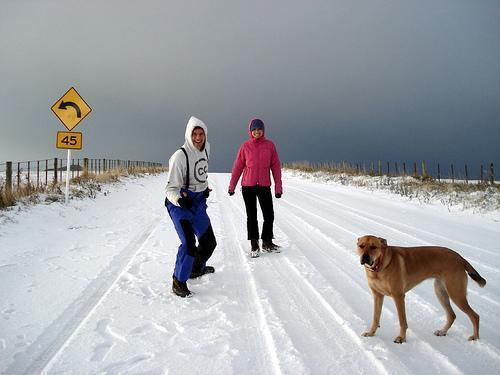How many people are there?
Give a very brief answer. 2. How many people can be seen?
Give a very brief answer. 2. How many giraffe are there?
Give a very brief answer. 0. 